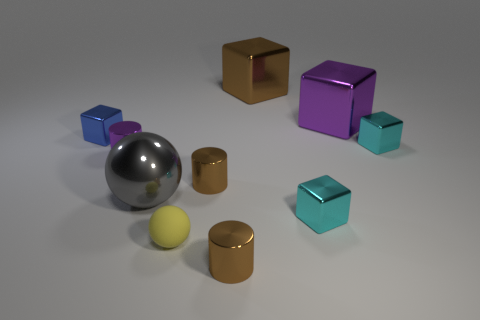Subtract all blue metallic cubes. How many cubes are left? 4 Subtract all blue spheres. How many brown cylinders are left? 2 Subtract all blue cubes. How many cubes are left? 4 Subtract 1 cylinders. How many cylinders are left? 2 Subtract all gray cubes. Subtract all red balls. How many cubes are left? 5 Subtract all balls. How many objects are left? 8 Add 8 yellow objects. How many yellow objects are left? 9 Add 6 big brown shiny things. How many big brown shiny things exist? 7 Subtract 2 brown cylinders. How many objects are left? 8 Subtract all tiny yellow objects. Subtract all tiny cyan metal cubes. How many objects are left? 7 